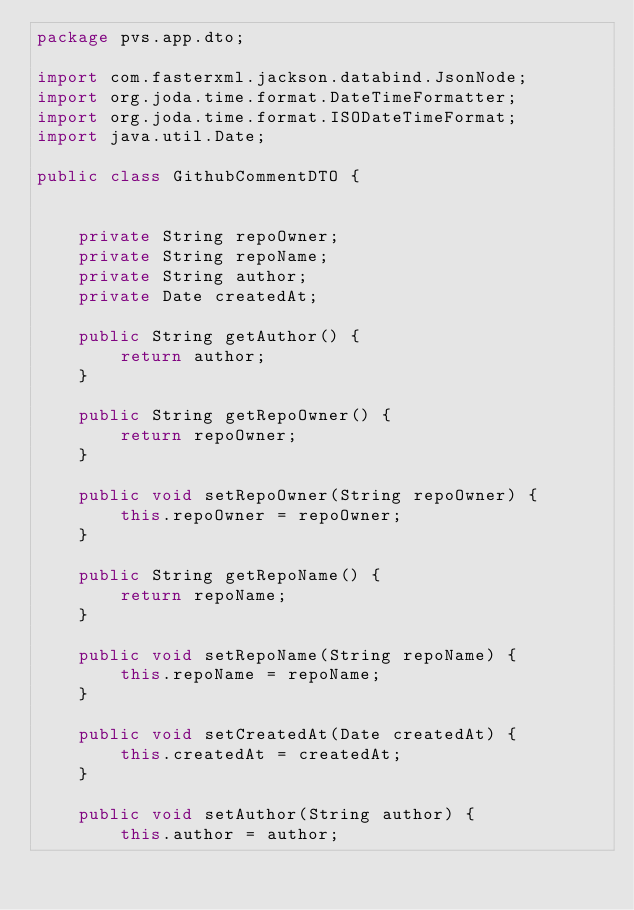<code> <loc_0><loc_0><loc_500><loc_500><_Java_>package pvs.app.dto;

import com.fasterxml.jackson.databind.JsonNode;
import org.joda.time.format.DateTimeFormatter;
import org.joda.time.format.ISODateTimeFormat;
import java.util.Date;

public class GithubCommentDTO {


    private String repoOwner;
    private String repoName;
    private String author;
    private Date createdAt;

    public String getAuthor() {
        return author;
    }

    public String getRepoOwner() {
        return repoOwner;
    }

    public void setRepoOwner(String repoOwner) {
        this.repoOwner = repoOwner;
    }

    public String getRepoName() {
        return repoName;
    }

    public void setRepoName(String repoName) {
        this.repoName = repoName;
    }

    public void setCreatedAt(Date createdAt) {
        this.createdAt = createdAt;
    }

    public void setAuthor(String author) {
        this.author = author;</code> 